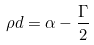Convert formula to latex. <formula><loc_0><loc_0><loc_500><loc_500>\rho d = \alpha - \frac { \Gamma } { 2 }</formula> 